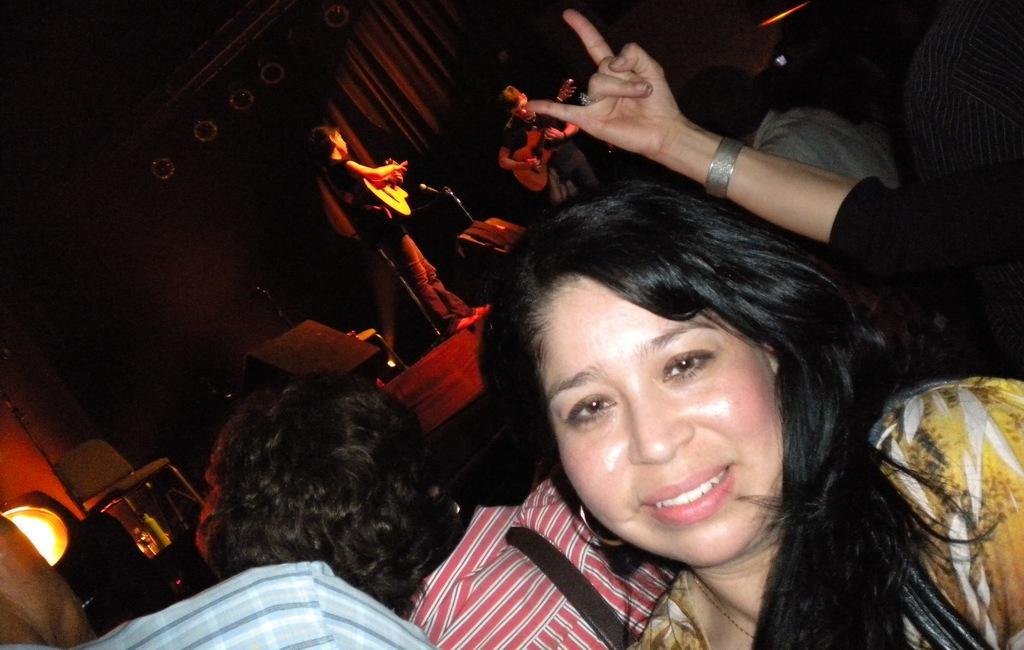In one or two sentences, can you explain what this image depicts? There are few people here. On the stage people are playing guitar. On the left there is a light and chair. 